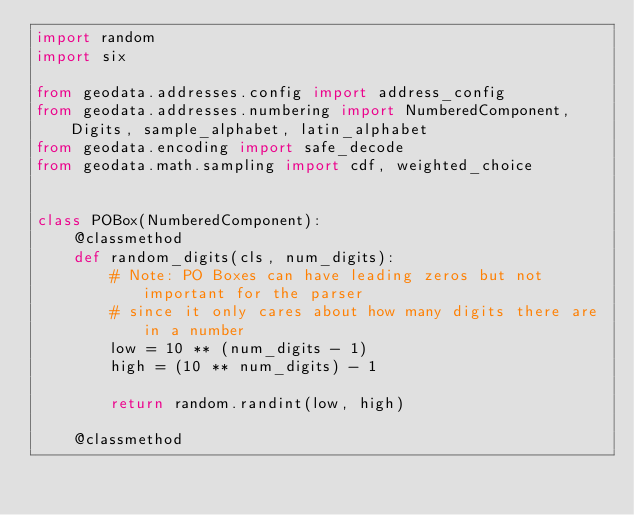Convert code to text. <code><loc_0><loc_0><loc_500><loc_500><_Python_>import random
import six

from geodata.addresses.config import address_config
from geodata.addresses.numbering import NumberedComponent, Digits, sample_alphabet, latin_alphabet
from geodata.encoding import safe_decode
from geodata.math.sampling import cdf, weighted_choice


class POBox(NumberedComponent):
    @classmethod
    def random_digits(cls, num_digits):
        # Note: PO Boxes can have leading zeros but not important for the parser
        # since it only cares about how many digits there are in a number
        low = 10 ** (num_digits - 1)
        high = (10 ** num_digits) - 1

        return random.randint(low, high)

    @classmethod</code> 